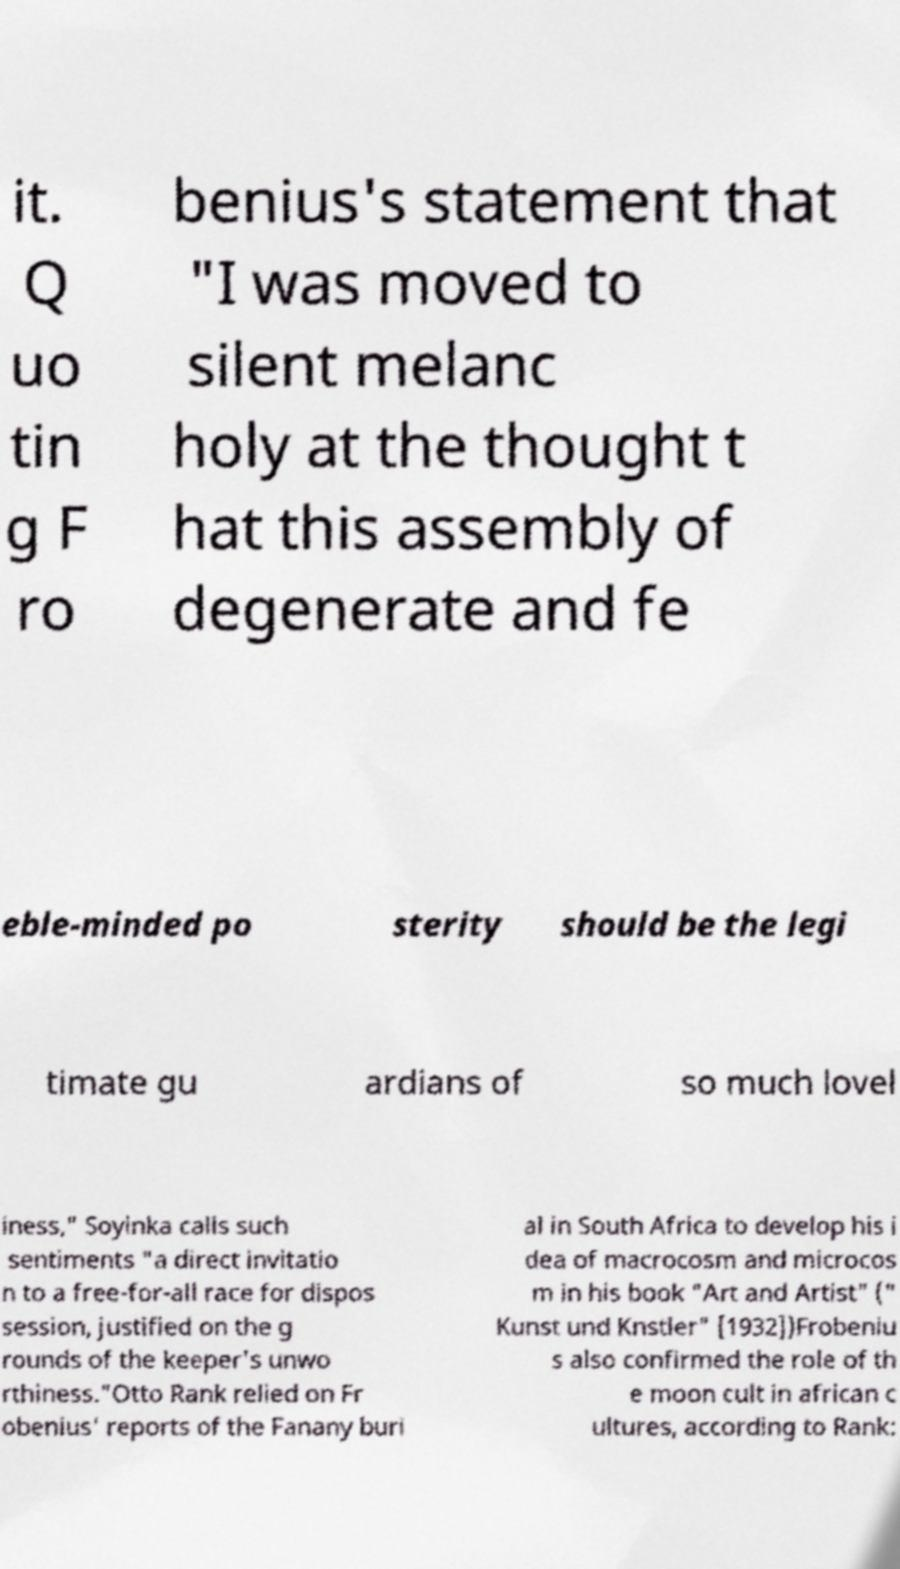Can you accurately transcribe the text from the provided image for me? it. Q uo tin g F ro benius's statement that "I was moved to silent melanc holy at the thought t hat this assembly of degenerate and fe eble-minded po sterity should be the legi timate gu ardians of so much lovel iness," Soyinka calls such sentiments "a direct invitatio n to a free-for-all race for dispos session, justified on the g rounds of the keeper's unwo rthiness."Otto Rank relied on Fr obenius' reports of the Fanany buri al in South Africa to develop his i dea of macrocosm and microcos m in his book "Art and Artist" (" Kunst und Knstler" [1932])Frobeniu s also confirmed the role of th e moon cult in african c ultures, according to Rank: 